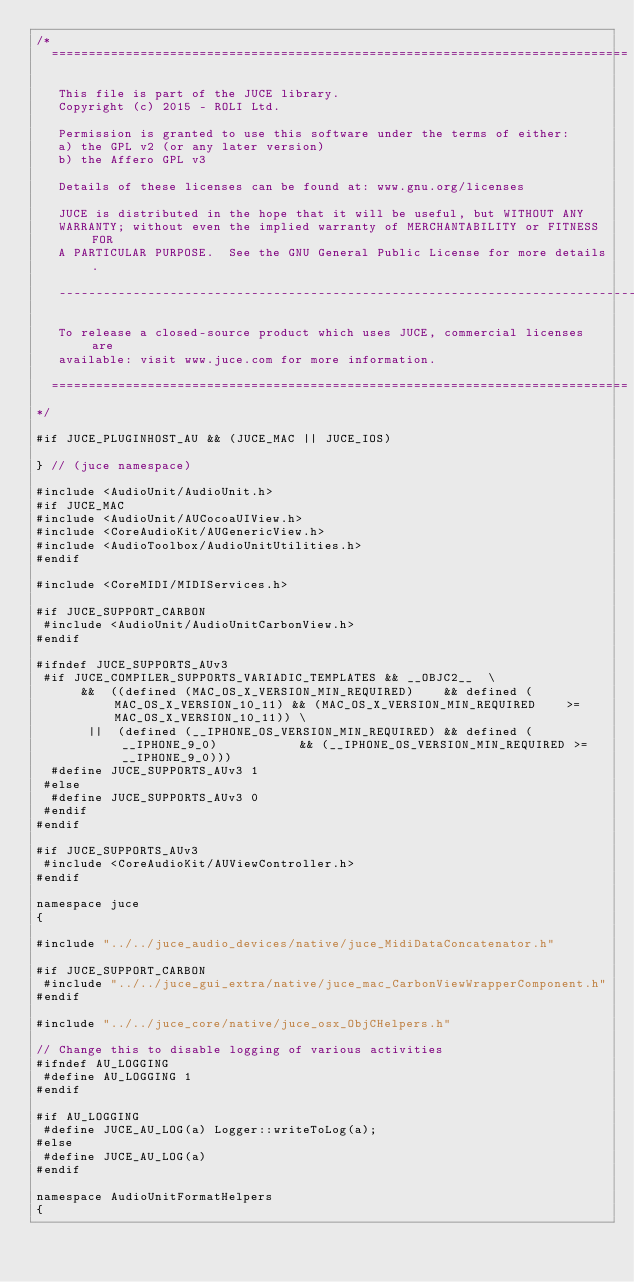<code> <loc_0><loc_0><loc_500><loc_500><_ObjectiveC_>/*
  ==============================================================================

   This file is part of the JUCE library.
   Copyright (c) 2015 - ROLI Ltd.

   Permission is granted to use this software under the terms of either:
   a) the GPL v2 (or any later version)
   b) the Affero GPL v3

   Details of these licenses can be found at: www.gnu.org/licenses

   JUCE is distributed in the hope that it will be useful, but WITHOUT ANY
   WARRANTY; without even the implied warranty of MERCHANTABILITY or FITNESS FOR
   A PARTICULAR PURPOSE.  See the GNU General Public License for more details.

   ------------------------------------------------------------------------------

   To release a closed-source product which uses JUCE, commercial licenses are
   available: visit www.juce.com for more information.

  ==============================================================================
*/

#if JUCE_PLUGINHOST_AU && (JUCE_MAC || JUCE_IOS)

} // (juce namespace)

#include <AudioUnit/AudioUnit.h>
#if JUCE_MAC
#include <AudioUnit/AUCocoaUIView.h>
#include <CoreAudioKit/AUGenericView.h>
#include <AudioToolbox/AudioUnitUtilities.h>
#endif

#include <CoreMIDI/MIDIServices.h>

#if JUCE_SUPPORT_CARBON
 #include <AudioUnit/AudioUnitCarbonView.h>
#endif

#ifndef JUCE_SUPPORTS_AUv3
 #if JUCE_COMPILER_SUPPORTS_VARIADIC_TEMPLATES && __OBJC2__  \
      &&  ((defined (MAC_OS_X_VERSION_MIN_REQUIRED)    && defined (MAC_OS_X_VERSION_10_11) && (MAC_OS_X_VERSION_MIN_REQUIRED    >= MAC_OS_X_VERSION_10_11)) \
       ||  (defined (__IPHONE_OS_VERSION_MIN_REQUIRED) && defined (__IPHONE_9_0)           && (__IPHONE_OS_VERSION_MIN_REQUIRED >= __IPHONE_9_0)))
  #define JUCE_SUPPORTS_AUv3 1
 #else
  #define JUCE_SUPPORTS_AUv3 0
 #endif
#endif

#if JUCE_SUPPORTS_AUv3
 #include <CoreAudioKit/AUViewController.h>
#endif

namespace juce
{

#include "../../juce_audio_devices/native/juce_MidiDataConcatenator.h"

#if JUCE_SUPPORT_CARBON
 #include "../../juce_gui_extra/native/juce_mac_CarbonViewWrapperComponent.h"
#endif

#include "../../juce_core/native/juce_osx_ObjCHelpers.h"

// Change this to disable logging of various activities
#ifndef AU_LOGGING
 #define AU_LOGGING 1
#endif

#if AU_LOGGING
 #define JUCE_AU_LOG(a) Logger::writeToLog(a);
#else
 #define JUCE_AU_LOG(a)
#endif

namespace AudioUnitFormatHelpers
{</code> 